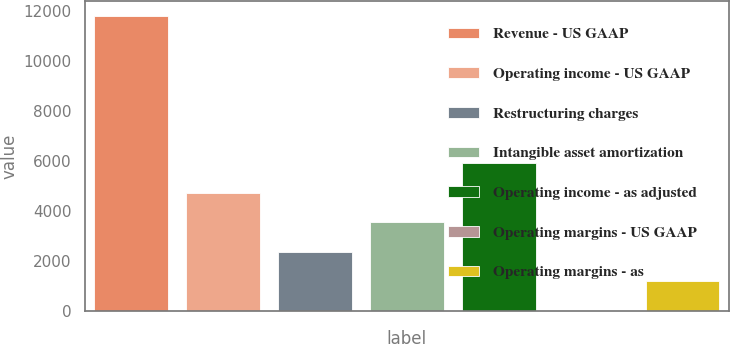<chart> <loc_0><loc_0><loc_500><loc_500><bar_chart><fcel>Revenue - US GAAP<fcel>Operating income - US GAAP<fcel>Restructuring charges<fcel>Intangible asset amortization<fcel>Operating income - as adjusted<fcel>Operating margins - US GAAP<fcel>Operating margins - as<nl><fcel>11815<fcel>4734.46<fcel>2374.28<fcel>3554.37<fcel>5914.55<fcel>14.1<fcel>1194.19<nl></chart> 